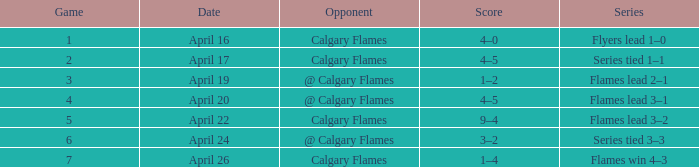Which date possesses a score of 4-5, and a game under 4? April 17. 